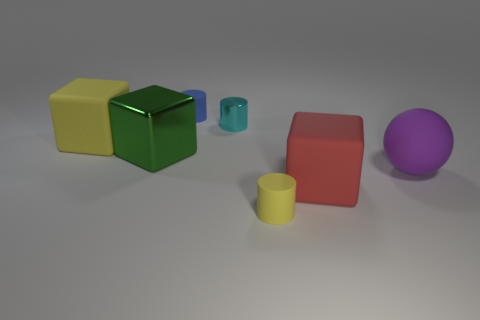Is there any other thing that has the same size as the cyan cylinder?
Give a very brief answer. Yes. What number of brown objects are either big balls or small matte balls?
Provide a succinct answer. 0. How many yellow matte cylinders have the same size as the red cube?
Give a very brief answer. 0. There is a thing that is in front of the green thing and to the left of the big red object; what color is it?
Offer a terse response. Yellow. Are there more large yellow rubber things that are in front of the yellow cylinder than yellow objects?
Make the answer very short. No. Is there a big rubber block?
Provide a short and direct response. Yes. Do the matte ball and the metallic cylinder have the same color?
Your response must be concise. No. How many small objects are either matte balls or yellow objects?
Keep it short and to the point. 1. Are there any other things of the same color as the large sphere?
Give a very brief answer. No. The red thing that is the same material as the blue cylinder is what shape?
Keep it short and to the point. Cube. 